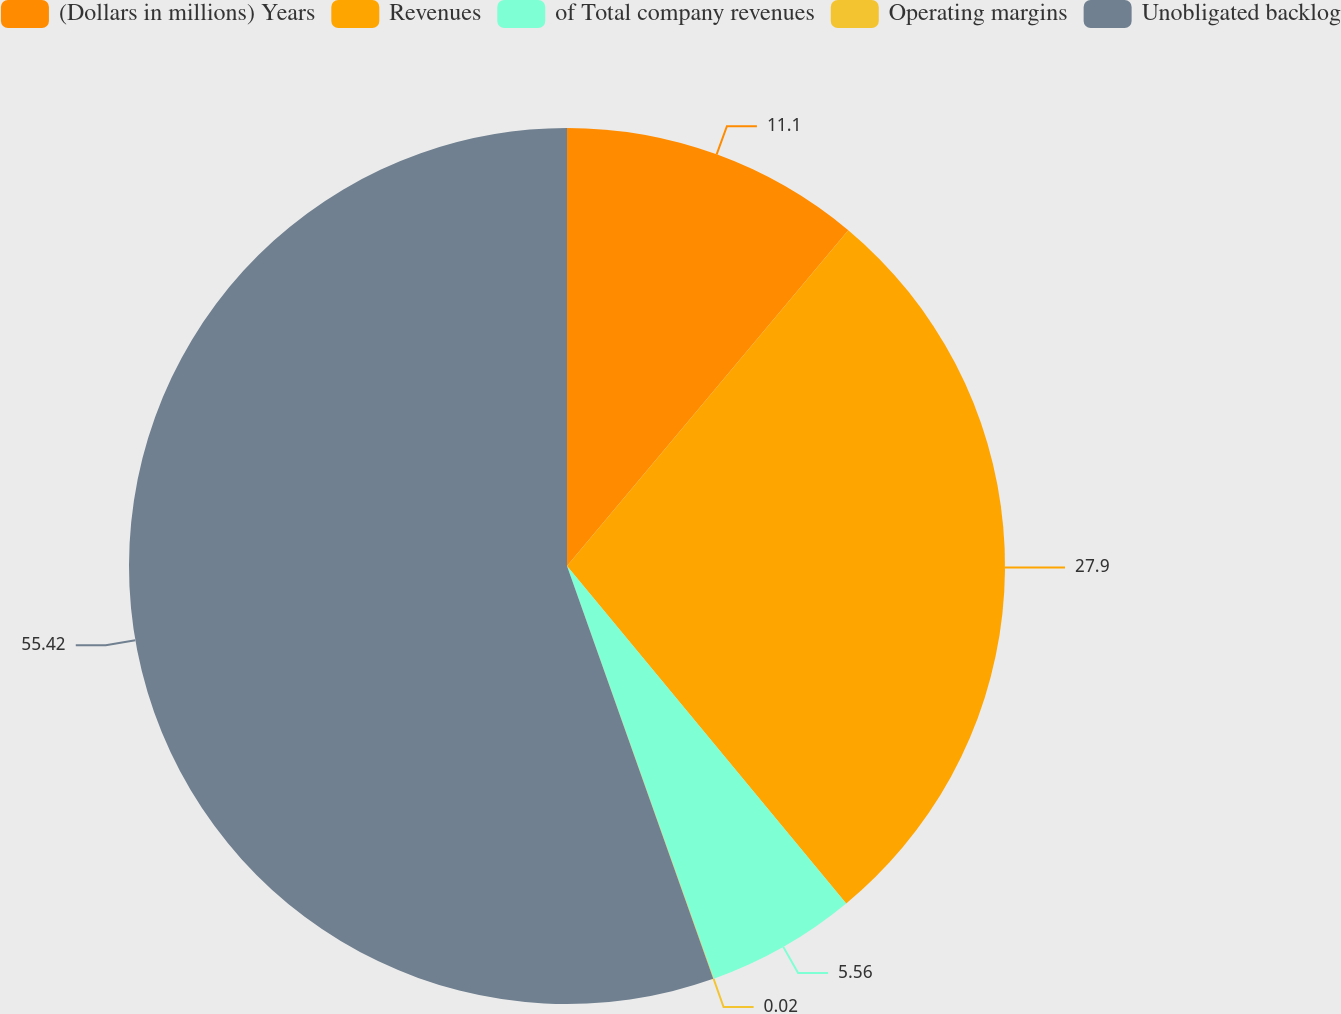<chart> <loc_0><loc_0><loc_500><loc_500><pie_chart><fcel>(Dollars in millions) Years<fcel>Revenues<fcel>of Total company revenues<fcel>Operating margins<fcel>Unobligated backlog<nl><fcel>11.1%<fcel>27.9%<fcel>5.56%<fcel>0.02%<fcel>55.42%<nl></chart> 